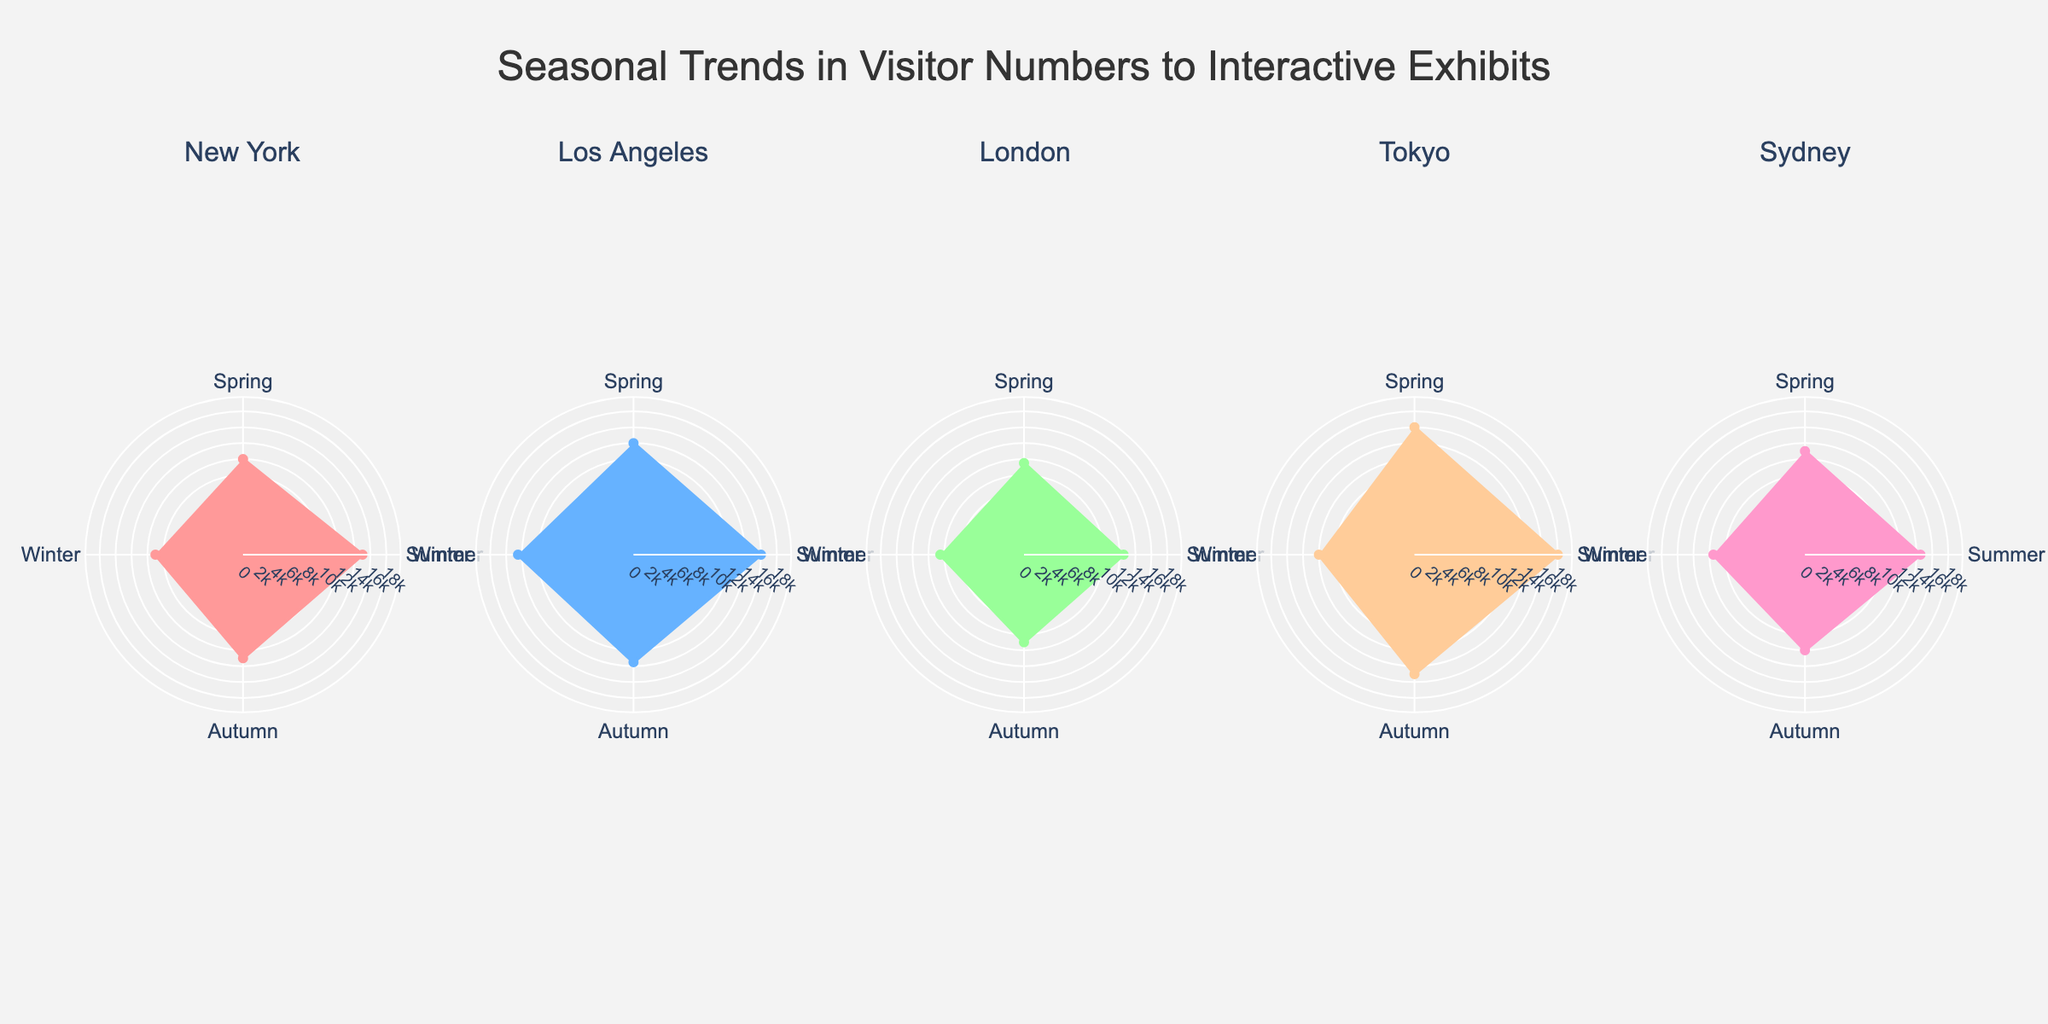What is the title of this figure? The title of a chart is usually located at the top and describes the overall theme or subject of the data presented.
Answer: Seasonal Trends in Visitor Numbers to Interactive Exhibits What location has the highest number of visitors during summer? To identify this, check the summer data point for each location and find the highest value. Tokyo has the highest at 18000.
Answer: Tokyo How many locations are presented in the figure? From the subplot titles or the number of individual rose charts, you can count the distinct locations. There are five locations represented: New York, Los Angeles, London, Tokyo, and Sydney.
Answer: 5 What's the difference in visitor numbers between Tokyo and London during winter? Subtract London's winter visitors (10500) from Tokyo's winter visitors (12000). The difference is 12000 - 10500 = 1500.
Answer: 1500 Which season has the lowest visitor numbers in London, and what is that number? By comparing the data points for each season in London's rose chart, winter has the lowest number with 10500 visitors.
Answer: Winter, 10500 In which city is the summer peak in visitor numbers not the highest among all seasons? Check each city to see if the summer value is not the highest: New York (15000, highest), Los Angeles (16000, highest), London (12500, highest), Tokyo (18000, highest), Sydney (14500, not highest - Spring is 16000). Only Sydney does not have the summer peak highest.
Answer: Sydney What is the average number of visitors in New York across all seasons? Sum the visitor numbers for all seasons in New York (12000 + 15000 + 13000 + 11000 = 51000) and divide by the number of seasons (4). The average is 51000 / 4 = 12750.
Answer: 12750 Among all the seasons, which one generally attracts the least visitors across all locations? Compare the aggregate visitor data for each season. Winter generally has the least visitors, as seen by the comparatively lower data points across all locations.
Answer: Winter Which season shows the greatest variation in visitor numbers between the different locations? Calculate the difference between the highest and lowest visitor numbers for each season: 
- Spring (16000 - 11500 = 4500)
- Summer (18000 - 12500 = 5500)
- Autumn (15000 - 11000 = 4000)
- Winter (14500 - 10500 = 4000)
Summer shows the greatest variation at 5500.
Answer: Summer Which city has the most consistent visitor numbers across all seasons, and what is the range of variation? The range of variation is the difference between the highest and lowest visitor numbers in each city. Checking all cities:
- New York: 15000 - 11000 = 4000
- Los Angeles: 16000 - 13500 = 2500
- London: 12500 - 10500 = 2000
- Tokyo: 18000 - 12000 = 6000
- Sydney: 14500 - 11500 = 3000
London has the most consistent visitor numbers with a variation range of 2000.
Answer: London, 2000 